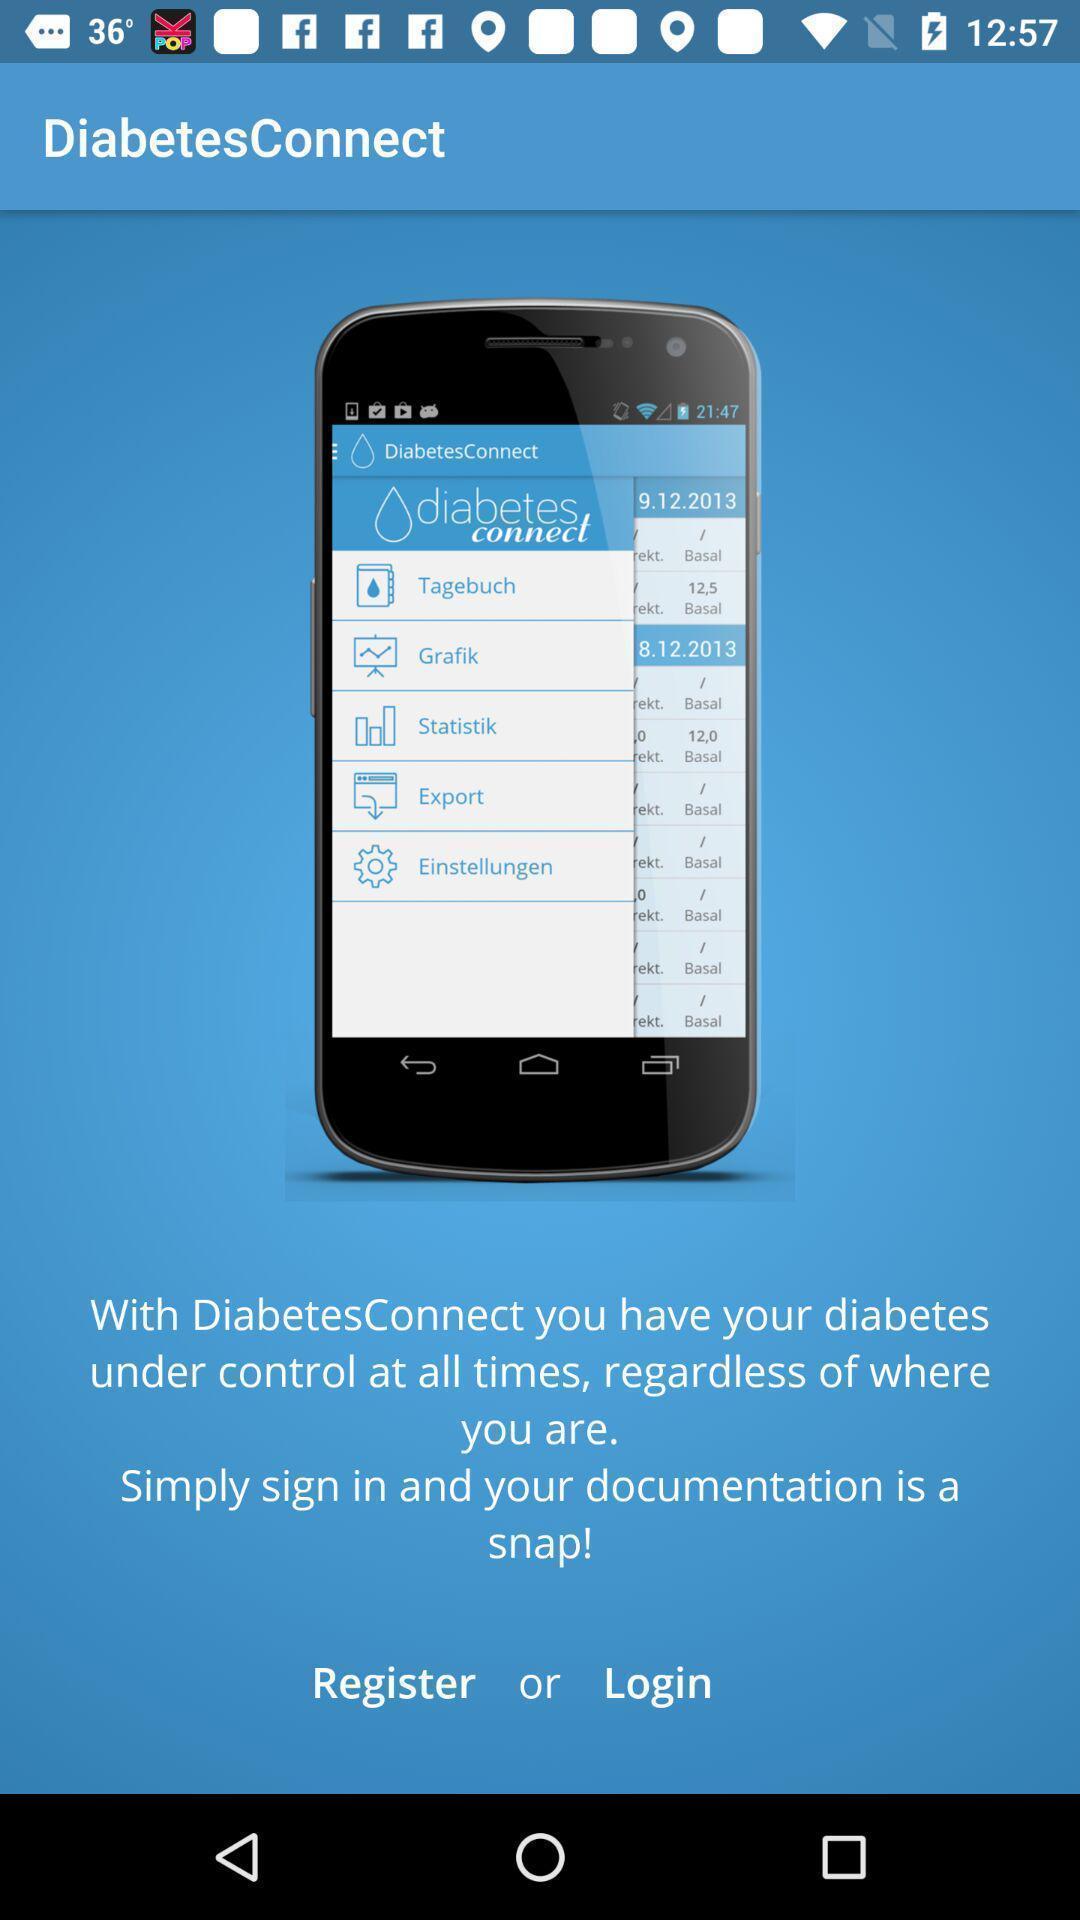What is the overall content of this screenshot? Welcome page for health care app. 